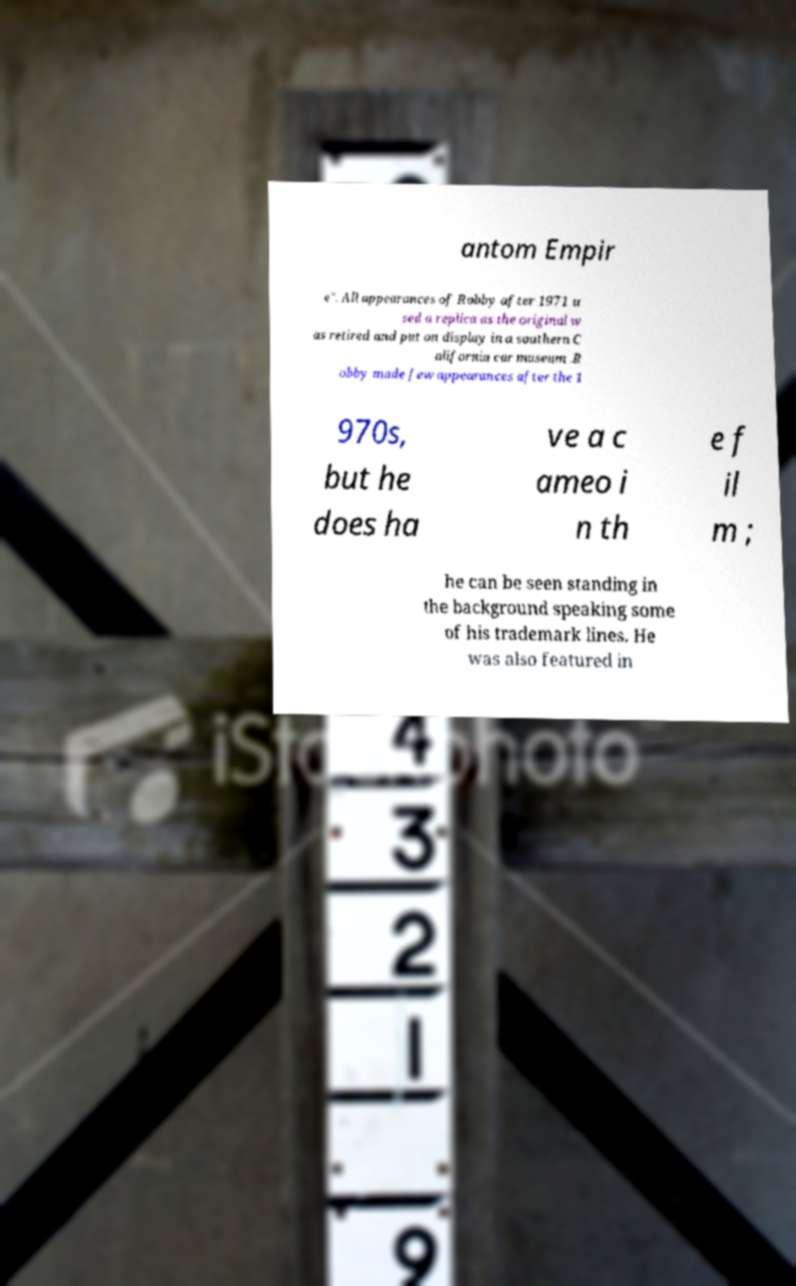What messages or text are displayed in this image? I need them in a readable, typed format. antom Empir e". All appearances of Robby after 1971 u sed a replica as the original w as retired and put on display in a southern C alifornia car museum .R obby made few appearances after the 1 970s, but he does ha ve a c ameo i n th e f il m ; he can be seen standing in the background speaking some of his trademark lines. He was also featured in 